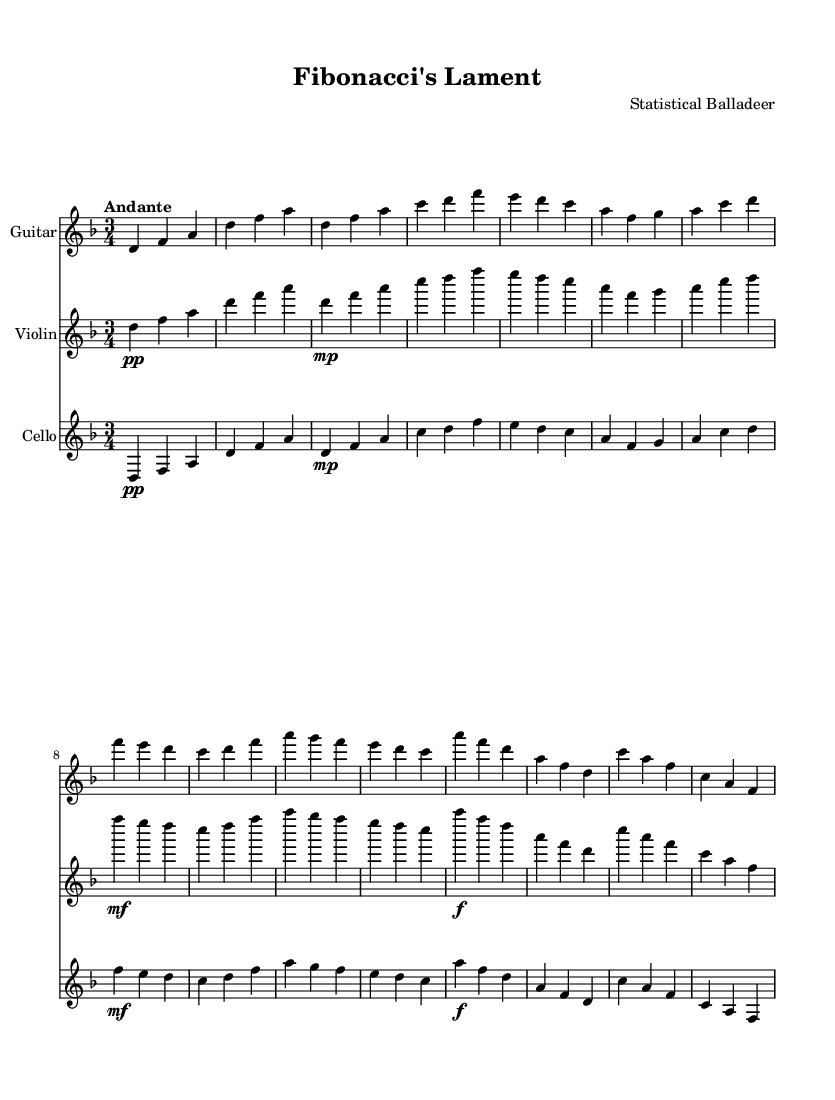What is the key signature of this music? The key signature is indicated at the beginning of the score. It shows two flat symbols, which correspond to the key of D minor.
Answer: D minor What is the time signature of this music? The time signature is found at the start of the score, showing a "3" over a "4", indicating three beats in each measure and that the quarter note receives one beat.
Answer: 3/4 What is the tempo marking of this piece? The tempo marking is present above the staff, stating "Andante", which indicates a moderately slow pace, typically around 76 to 108 beats per minute.
Answer: Andante How many staves are used for the instruments in the score? A count of the individual staves in the score reveals that there are three distinct staves, each representing a different instrument: guitar, violin, and cello.
Answer: Three What dynamics are indicated for the violin in the first measure? The dynamics for the violin are shown in the first measure as "pp", which stands for pianissimo, meaning very soft. This indicates how softly the violin should be played at the beginning.
Answer: pp Which instrument has the highest pitch throughout the piece? By comparing the pitches of the notes in all the instruments, it is determined that the violin consistently plays higher notes than the guitar and cello, making it the instrument with the highest pitch.
Answer: Violin What pattern appears in the melodic phrases of the guitar? Observing the guitar part, there is a recurring pattern of playing a descending sequence of notes followed by a leap upward, creating a recognizable melodic contour reflecting folk ballad tradition.
Answer: Descending sequence 